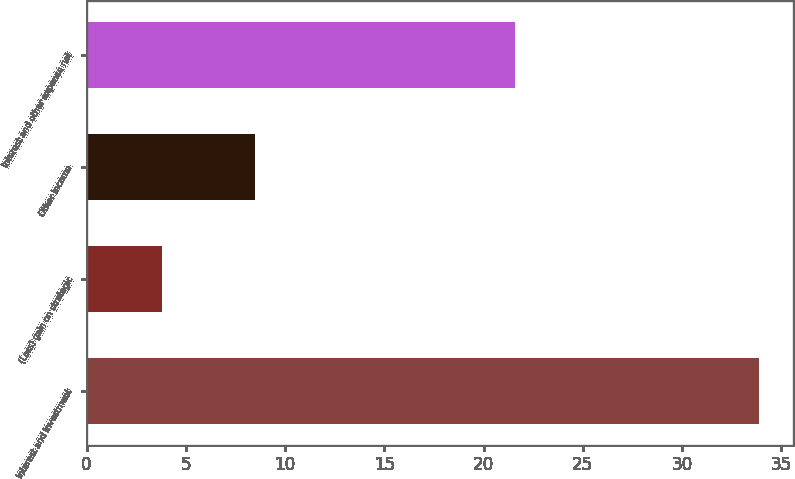<chart> <loc_0><loc_0><loc_500><loc_500><bar_chart><fcel>Interest and investment<fcel>(Loss) gain on strategic<fcel>Other income<fcel>Interest and other expense net<nl><fcel>33.9<fcel>3.8<fcel>8.5<fcel>21.6<nl></chart> 